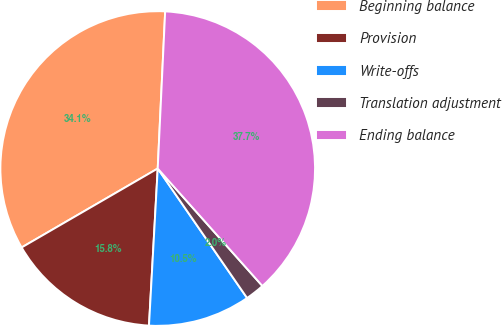Convert chart. <chart><loc_0><loc_0><loc_500><loc_500><pie_chart><fcel>Beginning balance<fcel>Provision<fcel>Write-offs<fcel>Translation adjustment<fcel>Ending balance<nl><fcel>34.12%<fcel>15.75%<fcel>10.5%<fcel>1.97%<fcel>37.66%<nl></chart> 